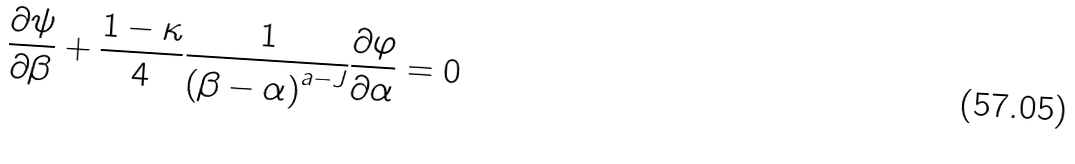Convert formula to latex. <formula><loc_0><loc_0><loc_500><loc_500>\frac { \partial \psi } { \partial \beta } + \frac { 1 - \kappa } { 4 } \frac { 1 } { \left ( { \beta - \alpha } \right ) ^ { a - J } } \frac { \partial \varphi } { \partial \alpha } = 0</formula> 